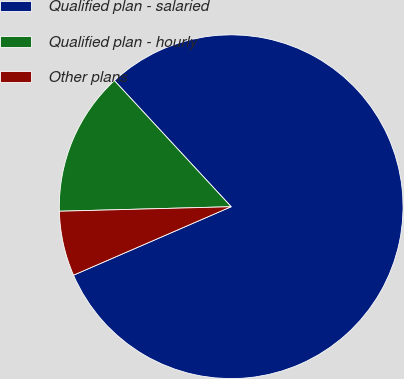Convert chart. <chart><loc_0><loc_0><loc_500><loc_500><pie_chart><fcel>Qualified plan - salaried<fcel>Qualified plan - hourly<fcel>Other plans<nl><fcel>80.37%<fcel>13.53%<fcel>6.1%<nl></chart> 